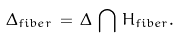Convert formula to latex. <formula><loc_0><loc_0><loc_500><loc_500>\Delta _ { f i b e r } \, = \, \Delta \, \bigcap \, H _ { f i b e r } .</formula> 